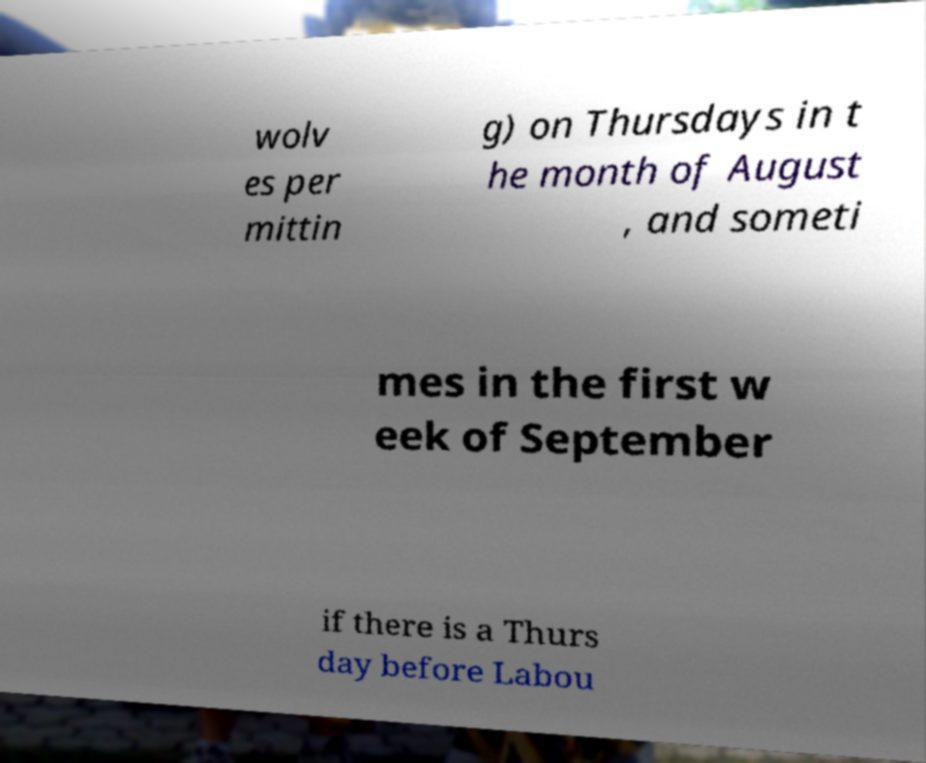Can you read and provide the text displayed in the image?This photo seems to have some interesting text. Can you extract and type it out for me? wolv es per mittin g) on Thursdays in t he month of August , and someti mes in the first w eek of September if there is a Thurs day before Labou 